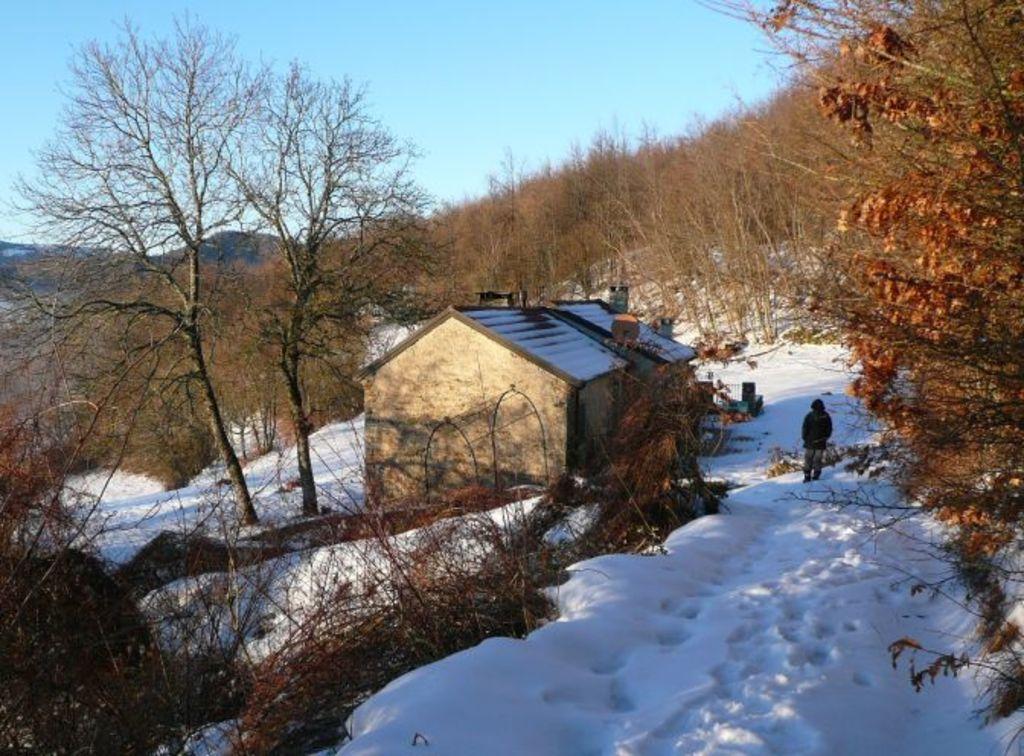Can you describe this image briefly? In this image there is a building here. Here there is a person. There are many trees, hills on the place. On the ground there is snow. The sky is clear. 